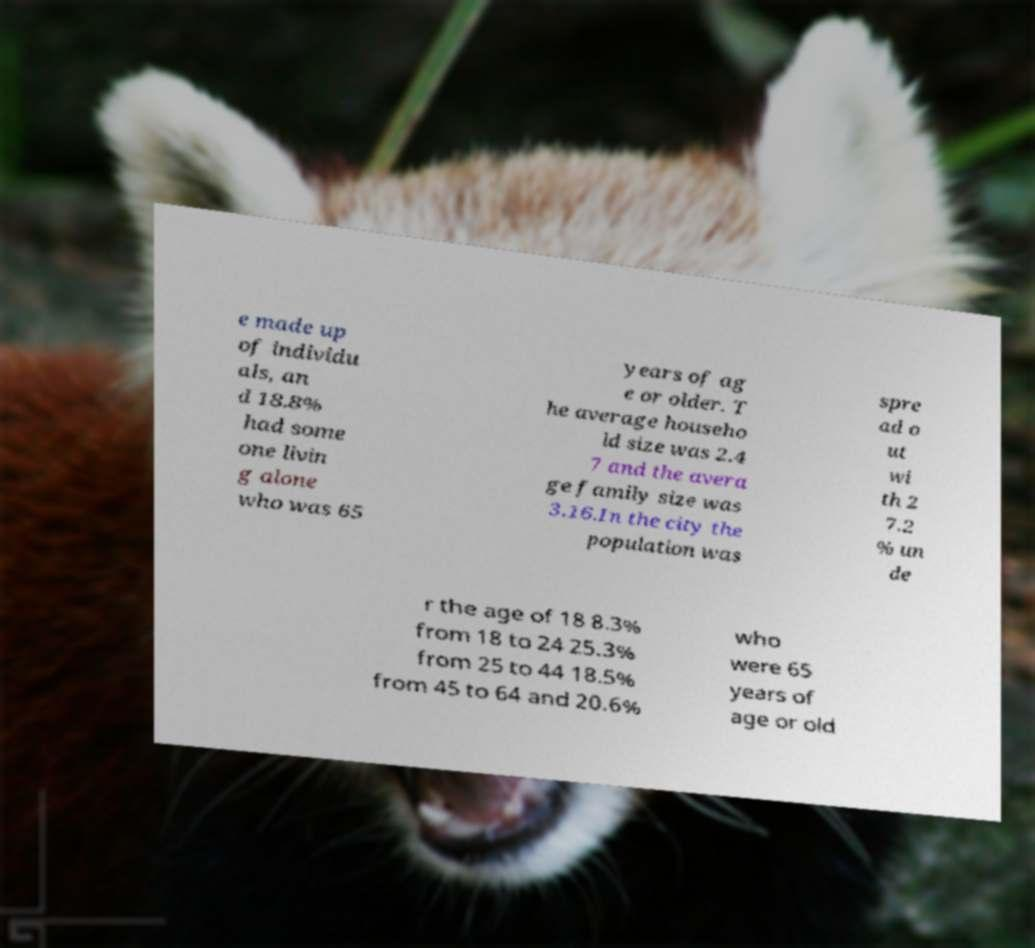For documentation purposes, I need the text within this image transcribed. Could you provide that? e made up of individu als, an d 18.8% had some one livin g alone who was 65 years of ag e or older. T he average househo ld size was 2.4 7 and the avera ge family size was 3.16.In the city the population was spre ad o ut wi th 2 7.2 % un de r the age of 18 8.3% from 18 to 24 25.3% from 25 to 44 18.5% from 45 to 64 and 20.6% who were 65 years of age or old 